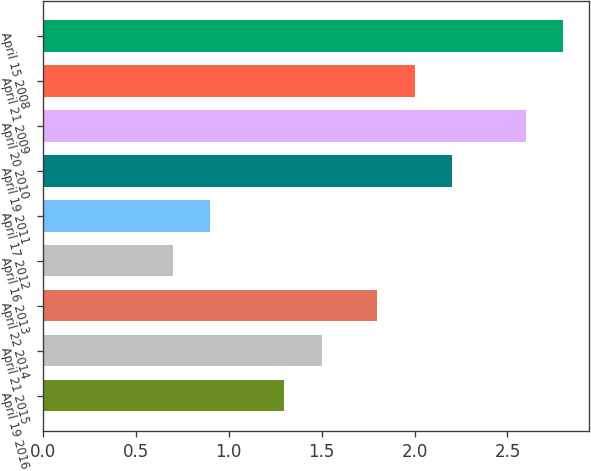Convert chart. <chart><loc_0><loc_0><loc_500><loc_500><bar_chart><fcel>April 19 2016<fcel>April 21 2015<fcel>April 22 2014<fcel>April 16 2013<fcel>April 17 2012<fcel>April 19 2011<fcel>April 20 2010<fcel>April 21 2009<fcel>April 15 2008<nl><fcel>1.3<fcel>1.5<fcel>1.8<fcel>0.7<fcel>0.9<fcel>2.2<fcel>2.6<fcel>2<fcel>2.8<nl></chart> 